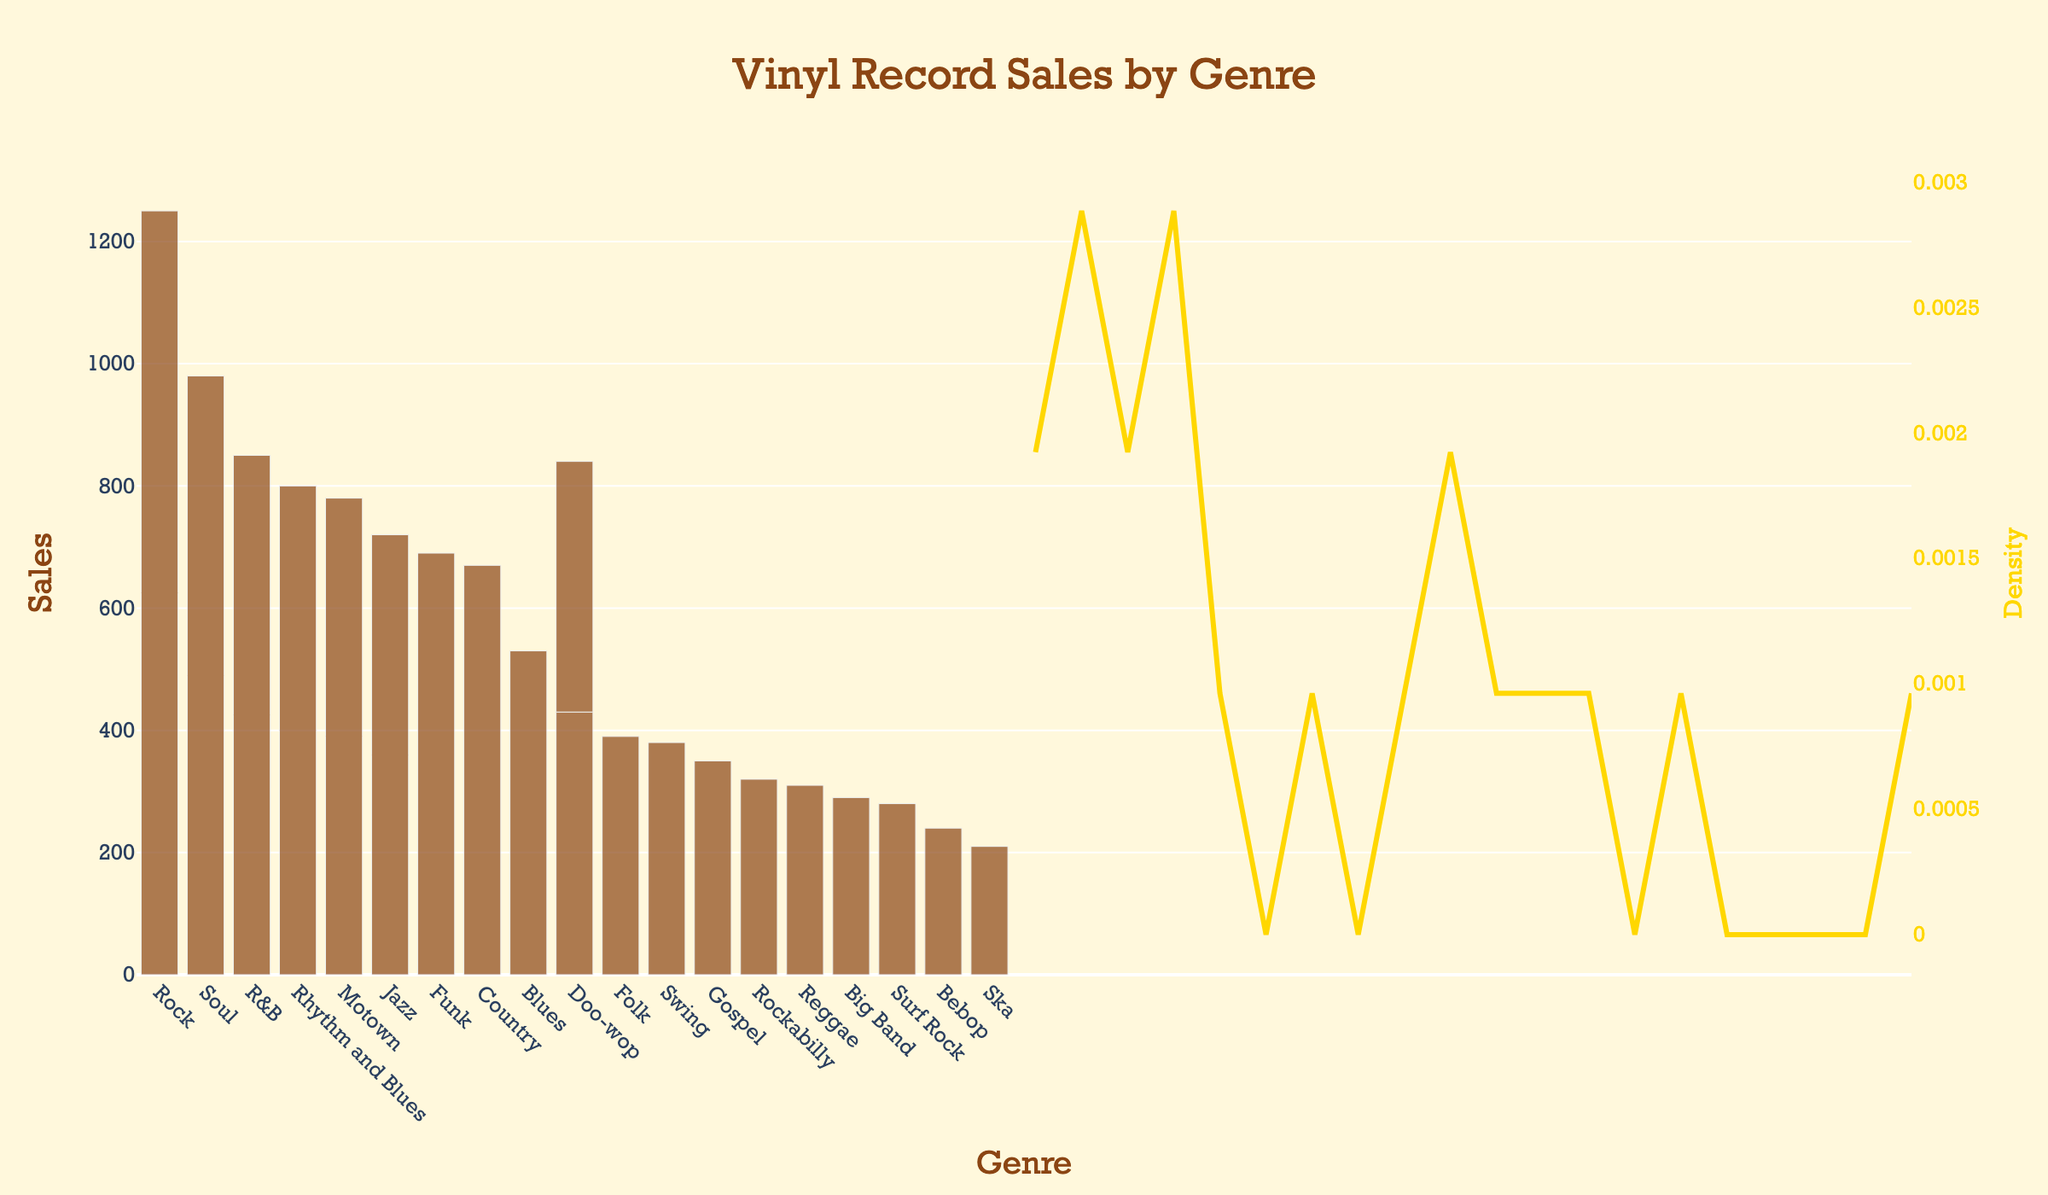What is the title of the plot? The title is located at the top center of the figure, stating what the plot is about. It reads "Vinyl Record Sales by Genre".
Answer: Vinyl Record Sales by Genre What is the genre with the highest sales? By examining the height of the bars in the bar plot, the 'Rock' genre has the tallest bar, indicating the highest sales.
Answer: Rock How many genres have sales greater than 700? By counting all the bars that reach above the 700 mark on the y-axis, there are six genres: Rock, Soul, R&B, Rhythm and Blues, Jazz, and Motown.
Answer: Six Which genre has the lowest record sales, and what is the value? The shortest bar in the histogram indicates the lowest sales, which corresponds to 'Bebop' with a sales value of 240.
Answer: Bebop, 240 What is the median sales value across all genres? Arranging all sales values in ascending order and determining the middle value, we find the median sales value to be 400 (the average of the 10th and 11th values from the sorted list).
Answer: 400 How does the sales of the 'Jazz' genre compare to 'Funk'? By comparing the bar heights, 'Jazz' has sales of 720 while 'Funk' has sales of 690. 'Jazz' sales are greater than 'Funk'.
Answer: Jazz has higher sales than Funk What is the total sales for the genres 'Rock', 'Soul', and 'Jazz'? Summing up the sales values of these three genres: Rock (1250) + Soul (980) + Jazz (720) = 2950.
Answer: 2950 What does the yellow density curve represent in this plot? The yellow density curve indicates the KDE (Kernel Density Estimation), which shows the distribution of the sales data and helps understand the sales data's probability density function.
Answer: Distribution of sales data Which genre sales fall closest to the peak of the density curve? The peak of the density curve appears around sales of 600-800. The genres closest to this range are Jazz (720) and Motown (780).
Answer: Jazz and Motown How many genres have sales between 300 and 700? Counting the number of bars whose heights fall within the 300 to 700 range: Doo-wop, Swing, Rockabilly, Gospel, Surf Rock, Folk, Reggae, and Country total to eight genres.
Answer: Eight 